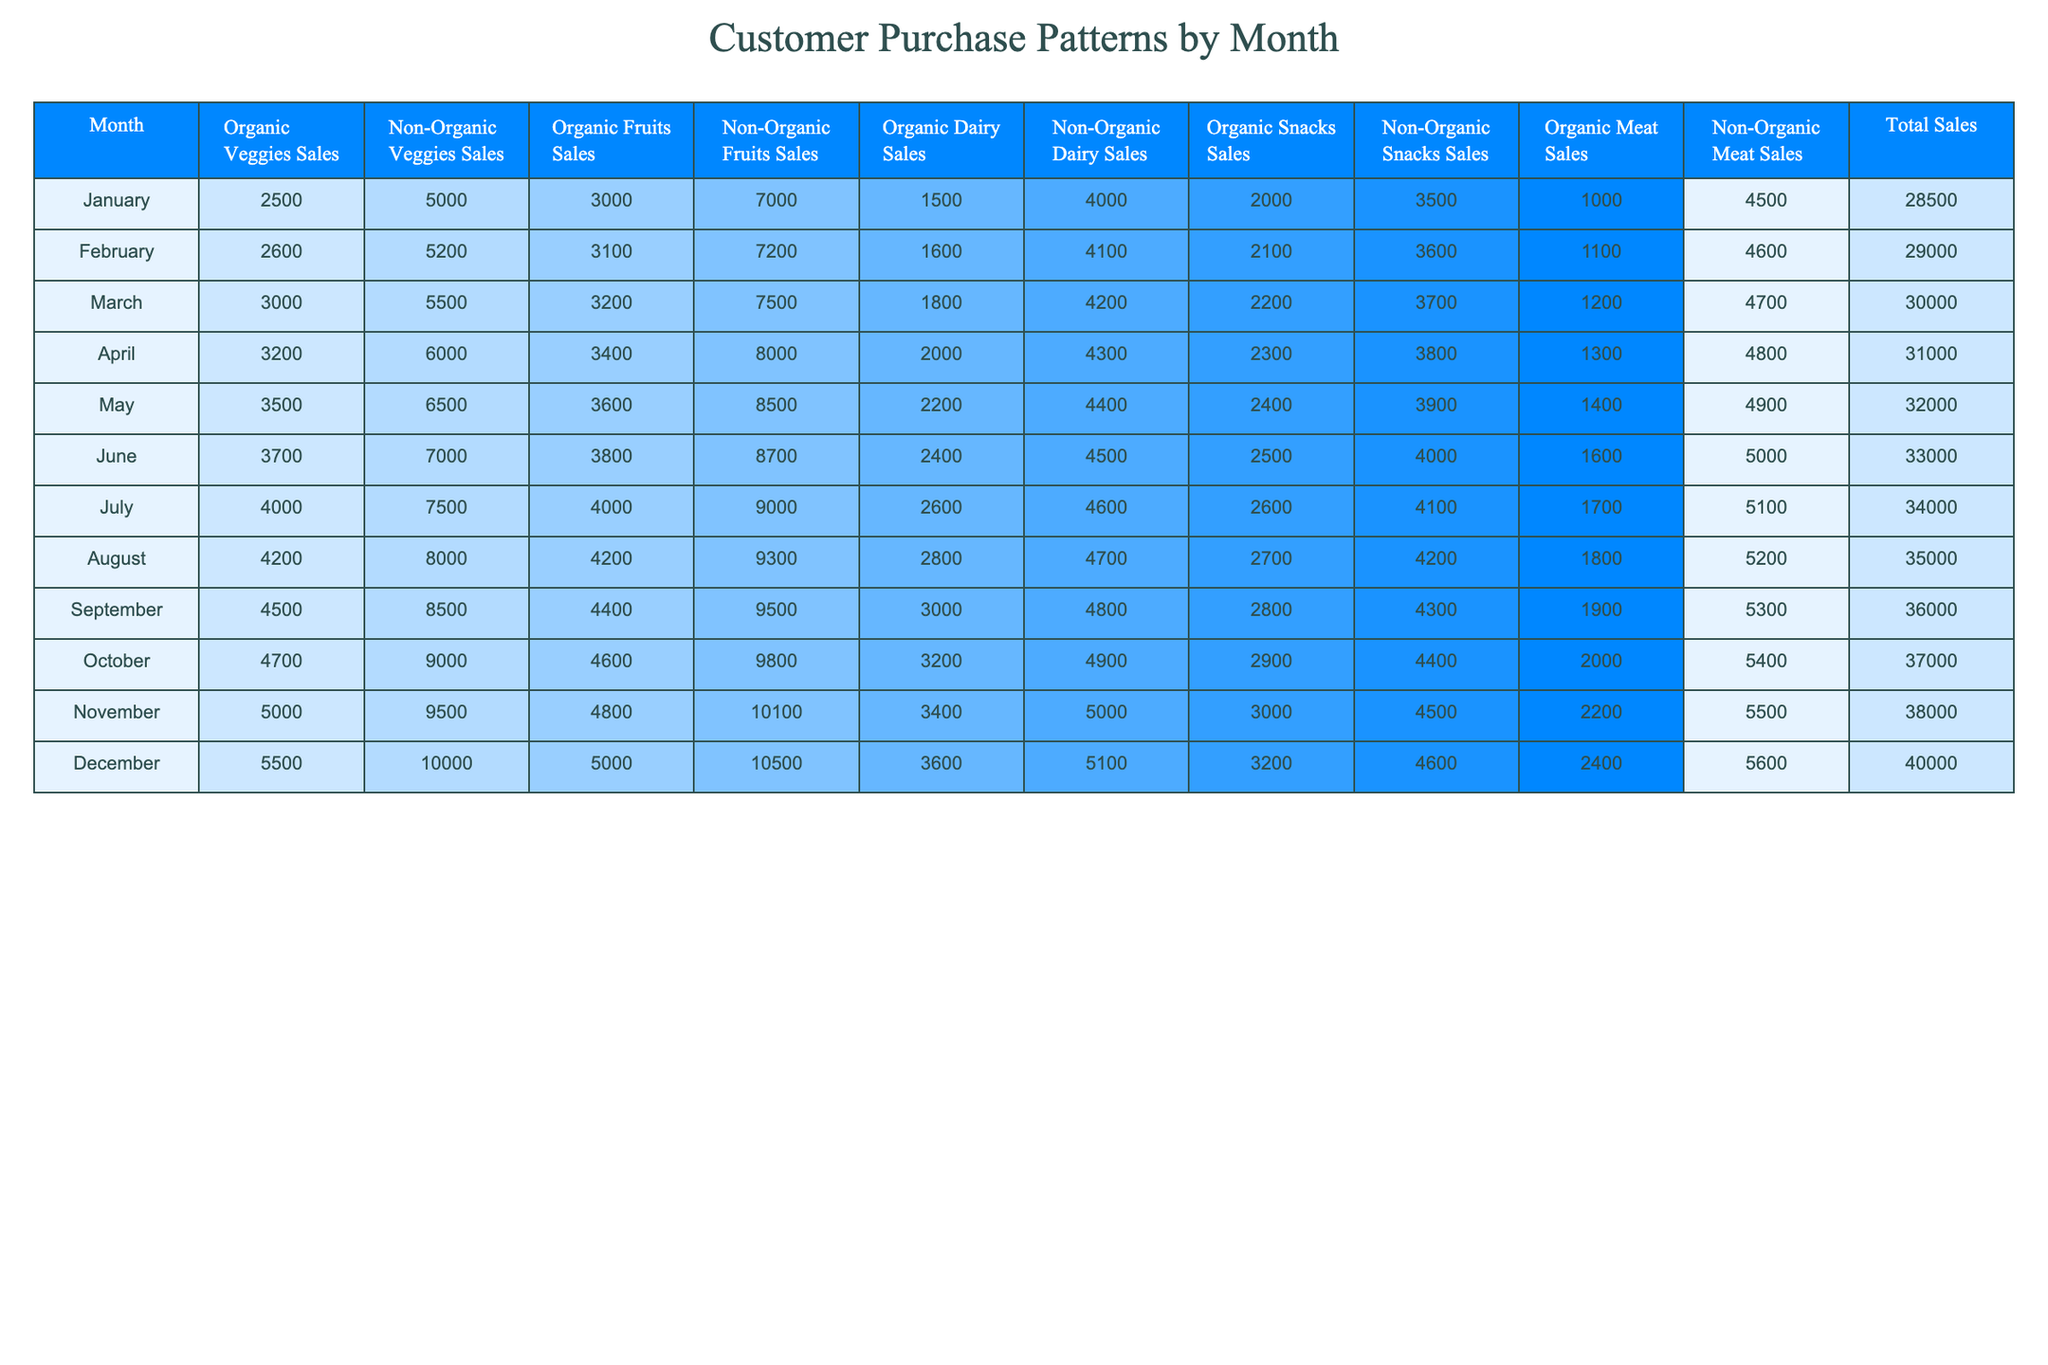What is the total organic dairy sales in December? In December, the total sales for organic dairy are explicitly stated in the table as 3600.
Answer: 3600 What is the non-organic fruit sales in July? The non-organic fruit sales for July can be found in the table, which shows a value of 9000.
Answer: 9000 Which month had the highest total sales? By examining the total sales column, December has the highest total, with a value of 40000.
Answer: December What is the difference in organic veggie sales between January and June? The organic veggie sales for January are 2500, and for June, they are 3700. The difference is 3700 - 2500 = 1200.
Answer: 1200 What were the average organic fruit sales over the months? Adding all organic fruit sales: (3000 + 3100 + 3200 + 3400 + 3600 + 3800 + 4000 + 4200 + 4400 + 4600 + 4800 + 5000) gives 45300. Dividing by 12 months results in an average of 3775.
Answer: 3775 Was there any month where non-organic snacks sales exceeded organic snacks sales? Looking at the table, in every month listed, non-organic snacks sales are higher than organic snacks sales, confirming it is true.
Answer: Yes In which month was the total sales the lowest? The lowest total sales are found in January, which has a total of 28500.
Answer: January What are the total organic meat sales for the first half of the year (January to June)? By summing the organic meat sales for those months: (1000 + 1100 + 1200 + 1300 + 1400 + 1600) results in a total of 7800.
Answer: 7800 What is the increase in organic veggie sales from March to November? Organic veggie sales in March are 3000, and in November, they are 5000. The increase is 5000 - 3000 = 2000.
Answer: 2000 Which month had the highest non-organic dairy sales? By checking the non-organic dairy sales column, November shows the highest sales with a value of 5500.
Answer: November What is the total sales for organic and non-organic fruits in August? In August, total organic fruits are 4200 and non-organic fruits are 9300. Their total is 4200 + 9300 = 13500.
Answer: 13500 Is the total organic veggies sales for March higher than the total non-organic veggies sales for June? In March, organic veggie sales are 3000, while non-organic veggie sales in June are 7000. Since 3000 is less than 7000, the statement is false.
Answer: No 